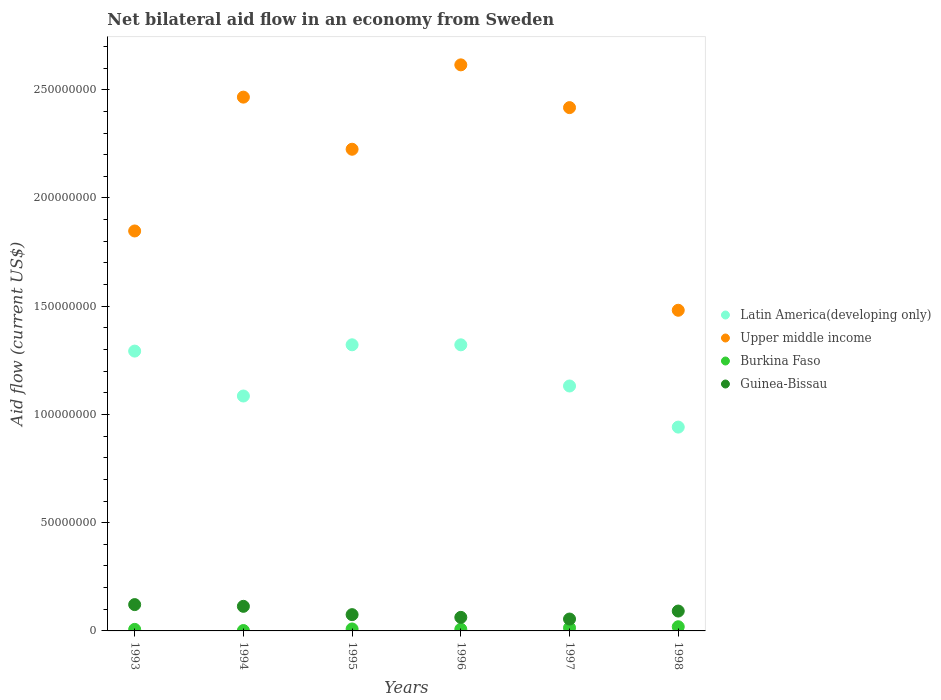How many different coloured dotlines are there?
Your answer should be compact. 4. What is the net bilateral aid flow in Latin America(developing only) in 1998?
Your answer should be compact. 9.42e+07. Across all years, what is the maximum net bilateral aid flow in Upper middle income?
Your answer should be very brief. 2.61e+08. Across all years, what is the minimum net bilateral aid flow in Latin America(developing only)?
Your answer should be compact. 9.42e+07. In which year was the net bilateral aid flow in Upper middle income maximum?
Provide a short and direct response. 1996. In which year was the net bilateral aid flow in Burkina Faso minimum?
Offer a terse response. 1994. What is the total net bilateral aid flow in Upper middle income in the graph?
Make the answer very short. 1.31e+09. What is the difference between the net bilateral aid flow in Guinea-Bissau in 1993 and that in 1995?
Offer a very short reply. 4.64e+06. What is the difference between the net bilateral aid flow in Guinea-Bissau in 1995 and the net bilateral aid flow in Upper middle income in 1996?
Offer a terse response. -2.54e+08. What is the average net bilateral aid flow in Guinea-Bissau per year?
Provide a succinct answer. 8.66e+06. In the year 1994, what is the difference between the net bilateral aid flow in Guinea-Bissau and net bilateral aid flow in Burkina Faso?
Your answer should be compact. 1.12e+07. In how many years, is the net bilateral aid flow in Latin America(developing only) greater than 10000000 US$?
Your answer should be very brief. 6. What is the ratio of the net bilateral aid flow in Burkina Faso in 1996 to that in 1997?
Keep it short and to the point. 0.55. Is the net bilateral aid flow in Upper middle income in 1995 less than that in 1997?
Make the answer very short. Yes. Is the difference between the net bilateral aid flow in Guinea-Bissau in 1993 and 1994 greater than the difference between the net bilateral aid flow in Burkina Faso in 1993 and 1994?
Make the answer very short. Yes. What is the difference between the highest and the lowest net bilateral aid flow in Upper middle income?
Provide a succinct answer. 1.13e+08. In how many years, is the net bilateral aid flow in Burkina Faso greater than the average net bilateral aid flow in Burkina Faso taken over all years?
Give a very brief answer. 2. Is it the case that in every year, the sum of the net bilateral aid flow in Guinea-Bissau and net bilateral aid flow in Burkina Faso  is greater than the sum of net bilateral aid flow in Latin America(developing only) and net bilateral aid flow in Upper middle income?
Give a very brief answer. Yes. Does the graph contain any zero values?
Ensure brevity in your answer.  No. How are the legend labels stacked?
Make the answer very short. Vertical. What is the title of the graph?
Provide a succinct answer. Net bilateral aid flow in an economy from Sweden. What is the Aid flow (current US$) of Latin America(developing only) in 1993?
Give a very brief answer. 1.29e+08. What is the Aid flow (current US$) of Upper middle income in 1993?
Give a very brief answer. 1.85e+08. What is the Aid flow (current US$) in Burkina Faso in 1993?
Give a very brief answer. 7.10e+05. What is the Aid flow (current US$) of Guinea-Bissau in 1993?
Give a very brief answer. 1.22e+07. What is the Aid flow (current US$) of Latin America(developing only) in 1994?
Provide a succinct answer. 1.09e+08. What is the Aid flow (current US$) in Upper middle income in 1994?
Provide a succinct answer. 2.47e+08. What is the Aid flow (current US$) in Burkina Faso in 1994?
Make the answer very short. 1.80e+05. What is the Aid flow (current US$) of Guinea-Bissau in 1994?
Provide a succinct answer. 1.14e+07. What is the Aid flow (current US$) in Latin America(developing only) in 1995?
Keep it short and to the point. 1.32e+08. What is the Aid flow (current US$) of Upper middle income in 1995?
Your answer should be very brief. 2.22e+08. What is the Aid flow (current US$) of Burkina Faso in 1995?
Your answer should be very brief. 9.10e+05. What is the Aid flow (current US$) in Guinea-Bissau in 1995?
Keep it short and to the point. 7.52e+06. What is the Aid flow (current US$) in Latin America(developing only) in 1996?
Provide a succinct answer. 1.32e+08. What is the Aid flow (current US$) of Upper middle income in 1996?
Make the answer very short. 2.61e+08. What is the Aid flow (current US$) in Burkina Faso in 1996?
Ensure brevity in your answer.  7.90e+05. What is the Aid flow (current US$) in Guinea-Bissau in 1996?
Offer a terse response. 6.26e+06. What is the Aid flow (current US$) in Latin America(developing only) in 1997?
Your response must be concise. 1.13e+08. What is the Aid flow (current US$) in Upper middle income in 1997?
Ensure brevity in your answer.  2.42e+08. What is the Aid flow (current US$) of Burkina Faso in 1997?
Your response must be concise. 1.44e+06. What is the Aid flow (current US$) in Guinea-Bissau in 1997?
Offer a terse response. 5.49e+06. What is the Aid flow (current US$) of Latin America(developing only) in 1998?
Offer a very short reply. 9.42e+07. What is the Aid flow (current US$) in Upper middle income in 1998?
Your response must be concise. 1.48e+08. What is the Aid flow (current US$) in Burkina Faso in 1998?
Provide a succinct answer. 1.93e+06. What is the Aid flow (current US$) in Guinea-Bissau in 1998?
Your response must be concise. 9.18e+06. Across all years, what is the maximum Aid flow (current US$) in Latin America(developing only)?
Offer a very short reply. 1.32e+08. Across all years, what is the maximum Aid flow (current US$) in Upper middle income?
Give a very brief answer. 2.61e+08. Across all years, what is the maximum Aid flow (current US$) in Burkina Faso?
Give a very brief answer. 1.93e+06. Across all years, what is the maximum Aid flow (current US$) of Guinea-Bissau?
Make the answer very short. 1.22e+07. Across all years, what is the minimum Aid flow (current US$) in Latin America(developing only)?
Your answer should be compact. 9.42e+07. Across all years, what is the minimum Aid flow (current US$) of Upper middle income?
Keep it short and to the point. 1.48e+08. Across all years, what is the minimum Aid flow (current US$) in Guinea-Bissau?
Offer a very short reply. 5.49e+06. What is the total Aid flow (current US$) of Latin America(developing only) in the graph?
Ensure brevity in your answer.  7.09e+08. What is the total Aid flow (current US$) of Upper middle income in the graph?
Provide a succinct answer. 1.31e+09. What is the total Aid flow (current US$) in Burkina Faso in the graph?
Provide a succinct answer. 5.96e+06. What is the total Aid flow (current US$) of Guinea-Bissau in the graph?
Your answer should be compact. 5.20e+07. What is the difference between the Aid flow (current US$) in Latin America(developing only) in 1993 and that in 1994?
Offer a very short reply. 2.08e+07. What is the difference between the Aid flow (current US$) of Upper middle income in 1993 and that in 1994?
Your answer should be very brief. -6.18e+07. What is the difference between the Aid flow (current US$) in Burkina Faso in 1993 and that in 1994?
Make the answer very short. 5.30e+05. What is the difference between the Aid flow (current US$) of Latin America(developing only) in 1993 and that in 1995?
Provide a succinct answer. -2.91e+06. What is the difference between the Aid flow (current US$) in Upper middle income in 1993 and that in 1995?
Make the answer very short. -3.78e+07. What is the difference between the Aid flow (current US$) of Guinea-Bissau in 1993 and that in 1995?
Make the answer very short. 4.64e+06. What is the difference between the Aid flow (current US$) in Latin America(developing only) in 1993 and that in 1996?
Ensure brevity in your answer.  -2.90e+06. What is the difference between the Aid flow (current US$) of Upper middle income in 1993 and that in 1996?
Give a very brief answer. -7.67e+07. What is the difference between the Aid flow (current US$) in Guinea-Bissau in 1993 and that in 1996?
Provide a succinct answer. 5.90e+06. What is the difference between the Aid flow (current US$) of Latin America(developing only) in 1993 and that in 1997?
Provide a short and direct response. 1.61e+07. What is the difference between the Aid flow (current US$) of Upper middle income in 1993 and that in 1997?
Ensure brevity in your answer.  -5.70e+07. What is the difference between the Aid flow (current US$) in Burkina Faso in 1993 and that in 1997?
Provide a short and direct response. -7.30e+05. What is the difference between the Aid flow (current US$) in Guinea-Bissau in 1993 and that in 1997?
Keep it short and to the point. 6.67e+06. What is the difference between the Aid flow (current US$) of Latin America(developing only) in 1993 and that in 1998?
Your answer should be very brief. 3.51e+07. What is the difference between the Aid flow (current US$) of Upper middle income in 1993 and that in 1998?
Give a very brief answer. 3.66e+07. What is the difference between the Aid flow (current US$) in Burkina Faso in 1993 and that in 1998?
Offer a very short reply. -1.22e+06. What is the difference between the Aid flow (current US$) in Guinea-Bissau in 1993 and that in 1998?
Offer a terse response. 2.98e+06. What is the difference between the Aid flow (current US$) in Latin America(developing only) in 1994 and that in 1995?
Provide a succinct answer. -2.37e+07. What is the difference between the Aid flow (current US$) of Upper middle income in 1994 and that in 1995?
Offer a very short reply. 2.41e+07. What is the difference between the Aid flow (current US$) in Burkina Faso in 1994 and that in 1995?
Keep it short and to the point. -7.30e+05. What is the difference between the Aid flow (current US$) in Guinea-Bissau in 1994 and that in 1995?
Your answer should be compact. 3.84e+06. What is the difference between the Aid flow (current US$) in Latin America(developing only) in 1994 and that in 1996?
Provide a short and direct response. -2.36e+07. What is the difference between the Aid flow (current US$) in Upper middle income in 1994 and that in 1996?
Make the answer very short. -1.49e+07. What is the difference between the Aid flow (current US$) in Burkina Faso in 1994 and that in 1996?
Offer a terse response. -6.10e+05. What is the difference between the Aid flow (current US$) in Guinea-Bissau in 1994 and that in 1996?
Provide a succinct answer. 5.10e+06. What is the difference between the Aid flow (current US$) in Latin America(developing only) in 1994 and that in 1997?
Offer a terse response. -4.63e+06. What is the difference between the Aid flow (current US$) in Upper middle income in 1994 and that in 1997?
Provide a succinct answer. 4.84e+06. What is the difference between the Aid flow (current US$) in Burkina Faso in 1994 and that in 1997?
Your response must be concise. -1.26e+06. What is the difference between the Aid flow (current US$) in Guinea-Bissau in 1994 and that in 1997?
Provide a short and direct response. 5.87e+06. What is the difference between the Aid flow (current US$) in Latin America(developing only) in 1994 and that in 1998?
Your answer should be compact. 1.44e+07. What is the difference between the Aid flow (current US$) of Upper middle income in 1994 and that in 1998?
Give a very brief answer. 9.84e+07. What is the difference between the Aid flow (current US$) of Burkina Faso in 1994 and that in 1998?
Ensure brevity in your answer.  -1.75e+06. What is the difference between the Aid flow (current US$) of Guinea-Bissau in 1994 and that in 1998?
Your answer should be very brief. 2.18e+06. What is the difference between the Aid flow (current US$) in Upper middle income in 1995 and that in 1996?
Ensure brevity in your answer.  -3.90e+07. What is the difference between the Aid flow (current US$) in Guinea-Bissau in 1995 and that in 1996?
Ensure brevity in your answer.  1.26e+06. What is the difference between the Aid flow (current US$) in Latin America(developing only) in 1995 and that in 1997?
Make the answer very short. 1.90e+07. What is the difference between the Aid flow (current US$) in Upper middle income in 1995 and that in 1997?
Your answer should be compact. -1.92e+07. What is the difference between the Aid flow (current US$) in Burkina Faso in 1995 and that in 1997?
Your answer should be very brief. -5.30e+05. What is the difference between the Aid flow (current US$) of Guinea-Bissau in 1995 and that in 1997?
Offer a very short reply. 2.03e+06. What is the difference between the Aid flow (current US$) in Latin America(developing only) in 1995 and that in 1998?
Your answer should be compact. 3.80e+07. What is the difference between the Aid flow (current US$) of Upper middle income in 1995 and that in 1998?
Give a very brief answer. 7.44e+07. What is the difference between the Aid flow (current US$) in Burkina Faso in 1995 and that in 1998?
Offer a terse response. -1.02e+06. What is the difference between the Aid flow (current US$) of Guinea-Bissau in 1995 and that in 1998?
Give a very brief answer. -1.66e+06. What is the difference between the Aid flow (current US$) in Latin America(developing only) in 1996 and that in 1997?
Ensure brevity in your answer.  1.90e+07. What is the difference between the Aid flow (current US$) of Upper middle income in 1996 and that in 1997?
Keep it short and to the point. 1.98e+07. What is the difference between the Aid flow (current US$) of Burkina Faso in 1996 and that in 1997?
Offer a terse response. -6.50e+05. What is the difference between the Aid flow (current US$) in Guinea-Bissau in 1996 and that in 1997?
Keep it short and to the point. 7.70e+05. What is the difference between the Aid flow (current US$) of Latin America(developing only) in 1996 and that in 1998?
Provide a short and direct response. 3.80e+07. What is the difference between the Aid flow (current US$) in Upper middle income in 1996 and that in 1998?
Keep it short and to the point. 1.13e+08. What is the difference between the Aid flow (current US$) in Burkina Faso in 1996 and that in 1998?
Offer a very short reply. -1.14e+06. What is the difference between the Aid flow (current US$) in Guinea-Bissau in 1996 and that in 1998?
Your answer should be very brief. -2.92e+06. What is the difference between the Aid flow (current US$) in Latin America(developing only) in 1997 and that in 1998?
Your response must be concise. 1.90e+07. What is the difference between the Aid flow (current US$) of Upper middle income in 1997 and that in 1998?
Provide a short and direct response. 9.36e+07. What is the difference between the Aid flow (current US$) of Burkina Faso in 1997 and that in 1998?
Ensure brevity in your answer.  -4.90e+05. What is the difference between the Aid flow (current US$) of Guinea-Bissau in 1997 and that in 1998?
Your answer should be compact. -3.69e+06. What is the difference between the Aid flow (current US$) in Latin America(developing only) in 1993 and the Aid flow (current US$) in Upper middle income in 1994?
Offer a terse response. -1.17e+08. What is the difference between the Aid flow (current US$) in Latin America(developing only) in 1993 and the Aid flow (current US$) in Burkina Faso in 1994?
Keep it short and to the point. 1.29e+08. What is the difference between the Aid flow (current US$) in Latin America(developing only) in 1993 and the Aid flow (current US$) in Guinea-Bissau in 1994?
Your response must be concise. 1.18e+08. What is the difference between the Aid flow (current US$) of Upper middle income in 1993 and the Aid flow (current US$) of Burkina Faso in 1994?
Make the answer very short. 1.85e+08. What is the difference between the Aid flow (current US$) of Upper middle income in 1993 and the Aid flow (current US$) of Guinea-Bissau in 1994?
Your answer should be very brief. 1.73e+08. What is the difference between the Aid flow (current US$) of Burkina Faso in 1993 and the Aid flow (current US$) of Guinea-Bissau in 1994?
Your answer should be compact. -1.06e+07. What is the difference between the Aid flow (current US$) in Latin America(developing only) in 1993 and the Aid flow (current US$) in Upper middle income in 1995?
Your response must be concise. -9.32e+07. What is the difference between the Aid flow (current US$) in Latin America(developing only) in 1993 and the Aid flow (current US$) in Burkina Faso in 1995?
Your answer should be compact. 1.28e+08. What is the difference between the Aid flow (current US$) of Latin America(developing only) in 1993 and the Aid flow (current US$) of Guinea-Bissau in 1995?
Provide a succinct answer. 1.22e+08. What is the difference between the Aid flow (current US$) in Upper middle income in 1993 and the Aid flow (current US$) in Burkina Faso in 1995?
Provide a succinct answer. 1.84e+08. What is the difference between the Aid flow (current US$) in Upper middle income in 1993 and the Aid flow (current US$) in Guinea-Bissau in 1995?
Provide a succinct answer. 1.77e+08. What is the difference between the Aid flow (current US$) in Burkina Faso in 1993 and the Aid flow (current US$) in Guinea-Bissau in 1995?
Your answer should be compact. -6.81e+06. What is the difference between the Aid flow (current US$) in Latin America(developing only) in 1993 and the Aid flow (current US$) in Upper middle income in 1996?
Your answer should be very brief. -1.32e+08. What is the difference between the Aid flow (current US$) in Latin America(developing only) in 1993 and the Aid flow (current US$) in Burkina Faso in 1996?
Offer a very short reply. 1.28e+08. What is the difference between the Aid flow (current US$) in Latin America(developing only) in 1993 and the Aid flow (current US$) in Guinea-Bissau in 1996?
Make the answer very short. 1.23e+08. What is the difference between the Aid flow (current US$) in Upper middle income in 1993 and the Aid flow (current US$) in Burkina Faso in 1996?
Make the answer very short. 1.84e+08. What is the difference between the Aid flow (current US$) in Upper middle income in 1993 and the Aid flow (current US$) in Guinea-Bissau in 1996?
Keep it short and to the point. 1.78e+08. What is the difference between the Aid flow (current US$) in Burkina Faso in 1993 and the Aid flow (current US$) in Guinea-Bissau in 1996?
Your answer should be very brief. -5.55e+06. What is the difference between the Aid flow (current US$) of Latin America(developing only) in 1993 and the Aid flow (current US$) of Upper middle income in 1997?
Offer a very short reply. -1.12e+08. What is the difference between the Aid flow (current US$) of Latin America(developing only) in 1993 and the Aid flow (current US$) of Burkina Faso in 1997?
Give a very brief answer. 1.28e+08. What is the difference between the Aid flow (current US$) of Latin America(developing only) in 1993 and the Aid flow (current US$) of Guinea-Bissau in 1997?
Give a very brief answer. 1.24e+08. What is the difference between the Aid flow (current US$) in Upper middle income in 1993 and the Aid flow (current US$) in Burkina Faso in 1997?
Give a very brief answer. 1.83e+08. What is the difference between the Aid flow (current US$) in Upper middle income in 1993 and the Aid flow (current US$) in Guinea-Bissau in 1997?
Your answer should be compact. 1.79e+08. What is the difference between the Aid flow (current US$) in Burkina Faso in 1993 and the Aid flow (current US$) in Guinea-Bissau in 1997?
Offer a terse response. -4.78e+06. What is the difference between the Aid flow (current US$) in Latin America(developing only) in 1993 and the Aid flow (current US$) in Upper middle income in 1998?
Offer a very short reply. -1.89e+07. What is the difference between the Aid flow (current US$) of Latin America(developing only) in 1993 and the Aid flow (current US$) of Burkina Faso in 1998?
Your response must be concise. 1.27e+08. What is the difference between the Aid flow (current US$) in Latin America(developing only) in 1993 and the Aid flow (current US$) in Guinea-Bissau in 1998?
Provide a short and direct response. 1.20e+08. What is the difference between the Aid flow (current US$) of Upper middle income in 1993 and the Aid flow (current US$) of Burkina Faso in 1998?
Provide a succinct answer. 1.83e+08. What is the difference between the Aid flow (current US$) in Upper middle income in 1993 and the Aid flow (current US$) in Guinea-Bissau in 1998?
Give a very brief answer. 1.76e+08. What is the difference between the Aid flow (current US$) of Burkina Faso in 1993 and the Aid flow (current US$) of Guinea-Bissau in 1998?
Your answer should be compact. -8.47e+06. What is the difference between the Aid flow (current US$) in Latin America(developing only) in 1994 and the Aid flow (current US$) in Upper middle income in 1995?
Ensure brevity in your answer.  -1.14e+08. What is the difference between the Aid flow (current US$) in Latin America(developing only) in 1994 and the Aid flow (current US$) in Burkina Faso in 1995?
Your answer should be compact. 1.08e+08. What is the difference between the Aid flow (current US$) in Latin America(developing only) in 1994 and the Aid flow (current US$) in Guinea-Bissau in 1995?
Give a very brief answer. 1.01e+08. What is the difference between the Aid flow (current US$) in Upper middle income in 1994 and the Aid flow (current US$) in Burkina Faso in 1995?
Provide a short and direct response. 2.46e+08. What is the difference between the Aid flow (current US$) of Upper middle income in 1994 and the Aid flow (current US$) of Guinea-Bissau in 1995?
Keep it short and to the point. 2.39e+08. What is the difference between the Aid flow (current US$) in Burkina Faso in 1994 and the Aid flow (current US$) in Guinea-Bissau in 1995?
Keep it short and to the point. -7.34e+06. What is the difference between the Aid flow (current US$) of Latin America(developing only) in 1994 and the Aid flow (current US$) of Upper middle income in 1996?
Make the answer very short. -1.53e+08. What is the difference between the Aid flow (current US$) in Latin America(developing only) in 1994 and the Aid flow (current US$) in Burkina Faso in 1996?
Your response must be concise. 1.08e+08. What is the difference between the Aid flow (current US$) of Latin America(developing only) in 1994 and the Aid flow (current US$) of Guinea-Bissau in 1996?
Provide a succinct answer. 1.02e+08. What is the difference between the Aid flow (current US$) in Upper middle income in 1994 and the Aid flow (current US$) in Burkina Faso in 1996?
Ensure brevity in your answer.  2.46e+08. What is the difference between the Aid flow (current US$) of Upper middle income in 1994 and the Aid flow (current US$) of Guinea-Bissau in 1996?
Provide a succinct answer. 2.40e+08. What is the difference between the Aid flow (current US$) in Burkina Faso in 1994 and the Aid flow (current US$) in Guinea-Bissau in 1996?
Your answer should be compact. -6.08e+06. What is the difference between the Aid flow (current US$) in Latin America(developing only) in 1994 and the Aid flow (current US$) in Upper middle income in 1997?
Provide a short and direct response. -1.33e+08. What is the difference between the Aid flow (current US$) in Latin America(developing only) in 1994 and the Aid flow (current US$) in Burkina Faso in 1997?
Give a very brief answer. 1.07e+08. What is the difference between the Aid flow (current US$) of Latin America(developing only) in 1994 and the Aid flow (current US$) of Guinea-Bissau in 1997?
Your answer should be compact. 1.03e+08. What is the difference between the Aid flow (current US$) of Upper middle income in 1994 and the Aid flow (current US$) of Burkina Faso in 1997?
Offer a very short reply. 2.45e+08. What is the difference between the Aid flow (current US$) in Upper middle income in 1994 and the Aid flow (current US$) in Guinea-Bissau in 1997?
Provide a short and direct response. 2.41e+08. What is the difference between the Aid flow (current US$) in Burkina Faso in 1994 and the Aid flow (current US$) in Guinea-Bissau in 1997?
Your answer should be very brief. -5.31e+06. What is the difference between the Aid flow (current US$) in Latin America(developing only) in 1994 and the Aid flow (current US$) in Upper middle income in 1998?
Ensure brevity in your answer.  -3.96e+07. What is the difference between the Aid flow (current US$) in Latin America(developing only) in 1994 and the Aid flow (current US$) in Burkina Faso in 1998?
Ensure brevity in your answer.  1.07e+08. What is the difference between the Aid flow (current US$) of Latin America(developing only) in 1994 and the Aid flow (current US$) of Guinea-Bissau in 1998?
Keep it short and to the point. 9.93e+07. What is the difference between the Aid flow (current US$) in Upper middle income in 1994 and the Aid flow (current US$) in Burkina Faso in 1998?
Provide a short and direct response. 2.45e+08. What is the difference between the Aid flow (current US$) in Upper middle income in 1994 and the Aid flow (current US$) in Guinea-Bissau in 1998?
Offer a terse response. 2.37e+08. What is the difference between the Aid flow (current US$) in Burkina Faso in 1994 and the Aid flow (current US$) in Guinea-Bissau in 1998?
Provide a short and direct response. -9.00e+06. What is the difference between the Aid flow (current US$) in Latin America(developing only) in 1995 and the Aid flow (current US$) in Upper middle income in 1996?
Keep it short and to the point. -1.29e+08. What is the difference between the Aid flow (current US$) in Latin America(developing only) in 1995 and the Aid flow (current US$) in Burkina Faso in 1996?
Offer a very short reply. 1.31e+08. What is the difference between the Aid flow (current US$) in Latin America(developing only) in 1995 and the Aid flow (current US$) in Guinea-Bissau in 1996?
Give a very brief answer. 1.26e+08. What is the difference between the Aid flow (current US$) of Upper middle income in 1995 and the Aid flow (current US$) of Burkina Faso in 1996?
Your response must be concise. 2.22e+08. What is the difference between the Aid flow (current US$) of Upper middle income in 1995 and the Aid flow (current US$) of Guinea-Bissau in 1996?
Offer a terse response. 2.16e+08. What is the difference between the Aid flow (current US$) of Burkina Faso in 1995 and the Aid flow (current US$) of Guinea-Bissau in 1996?
Offer a terse response. -5.35e+06. What is the difference between the Aid flow (current US$) of Latin America(developing only) in 1995 and the Aid flow (current US$) of Upper middle income in 1997?
Offer a very short reply. -1.10e+08. What is the difference between the Aid flow (current US$) in Latin America(developing only) in 1995 and the Aid flow (current US$) in Burkina Faso in 1997?
Offer a terse response. 1.31e+08. What is the difference between the Aid flow (current US$) of Latin America(developing only) in 1995 and the Aid flow (current US$) of Guinea-Bissau in 1997?
Make the answer very short. 1.27e+08. What is the difference between the Aid flow (current US$) in Upper middle income in 1995 and the Aid flow (current US$) in Burkina Faso in 1997?
Ensure brevity in your answer.  2.21e+08. What is the difference between the Aid flow (current US$) in Upper middle income in 1995 and the Aid flow (current US$) in Guinea-Bissau in 1997?
Ensure brevity in your answer.  2.17e+08. What is the difference between the Aid flow (current US$) in Burkina Faso in 1995 and the Aid flow (current US$) in Guinea-Bissau in 1997?
Offer a terse response. -4.58e+06. What is the difference between the Aid flow (current US$) of Latin America(developing only) in 1995 and the Aid flow (current US$) of Upper middle income in 1998?
Your answer should be compact. -1.60e+07. What is the difference between the Aid flow (current US$) of Latin America(developing only) in 1995 and the Aid flow (current US$) of Burkina Faso in 1998?
Provide a short and direct response. 1.30e+08. What is the difference between the Aid flow (current US$) of Latin America(developing only) in 1995 and the Aid flow (current US$) of Guinea-Bissau in 1998?
Your answer should be compact. 1.23e+08. What is the difference between the Aid flow (current US$) in Upper middle income in 1995 and the Aid flow (current US$) in Burkina Faso in 1998?
Offer a very short reply. 2.21e+08. What is the difference between the Aid flow (current US$) in Upper middle income in 1995 and the Aid flow (current US$) in Guinea-Bissau in 1998?
Offer a terse response. 2.13e+08. What is the difference between the Aid flow (current US$) of Burkina Faso in 1995 and the Aid flow (current US$) of Guinea-Bissau in 1998?
Your answer should be compact. -8.27e+06. What is the difference between the Aid flow (current US$) of Latin America(developing only) in 1996 and the Aid flow (current US$) of Upper middle income in 1997?
Your response must be concise. -1.10e+08. What is the difference between the Aid flow (current US$) of Latin America(developing only) in 1996 and the Aid flow (current US$) of Burkina Faso in 1997?
Your answer should be compact. 1.31e+08. What is the difference between the Aid flow (current US$) of Latin America(developing only) in 1996 and the Aid flow (current US$) of Guinea-Bissau in 1997?
Keep it short and to the point. 1.27e+08. What is the difference between the Aid flow (current US$) of Upper middle income in 1996 and the Aid flow (current US$) of Burkina Faso in 1997?
Provide a succinct answer. 2.60e+08. What is the difference between the Aid flow (current US$) of Upper middle income in 1996 and the Aid flow (current US$) of Guinea-Bissau in 1997?
Provide a short and direct response. 2.56e+08. What is the difference between the Aid flow (current US$) of Burkina Faso in 1996 and the Aid flow (current US$) of Guinea-Bissau in 1997?
Give a very brief answer. -4.70e+06. What is the difference between the Aid flow (current US$) of Latin America(developing only) in 1996 and the Aid flow (current US$) of Upper middle income in 1998?
Offer a very short reply. -1.60e+07. What is the difference between the Aid flow (current US$) in Latin America(developing only) in 1996 and the Aid flow (current US$) in Burkina Faso in 1998?
Your response must be concise. 1.30e+08. What is the difference between the Aid flow (current US$) of Latin America(developing only) in 1996 and the Aid flow (current US$) of Guinea-Bissau in 1998?
Your response must be concise. 1.23e+08. What is the difference between the Aid flow (current US$) of Upper middle income in 1996 and the Aid flow (current US$) of Burkina Faso in 1998?
Provide a short and direct response. 2.60e+08. What is the difference between the Aid flow (current US$) of Upper middle income in 1996 and the Aid flow (current US$) of Guinea-Bissau in 1998?
Ensure brevity in your answer.  2.52e+08. What is the difference between the Aid flow (current US$) in Burkina Faso in 1996 and the Aid flow (current US$) in Guinea-Bissau in 1998?
Offer a terse response. -8.39e+06. What is the difference between the Aid flow (current US$) in Latin America(developing only) in 1997 and the Aid flow (current US$) in Upper middle income in 1998?
Keep it short and to the point. -3.50e+07. What is the difference between the Aid flow (current US$) of Latin America(developing only) in 1997 and the Aid flow (current US$) of Burkina Faso in 1998?
Offer a terse response. 1.11e+08. What is the difference between the Aid flow (current US$) of Latin America(developing only) in 1997 and the Aid flow (current US$) of Guinea-Bissau in 1998?
Give a very brief answer. 1.04e+08. What is the difference between the Aid flow (current US$) in Upper middle income in 1997 and the Aid flow (current US$) in Burkina Faso in 1998?
Your answer should be very brief. 2.40e+08. What is the difference between the Aid flow (current US$) of Upper middle income in 1997 and the Aid flow (current US$) of Guinea-Bissau in 1998?
Keep it short and to the point. 2.33e+08. What is the difference between the Aid flow (current US$) in Burkina Faso in 1997 and the Aid flow (current US$) in Guinea-Bissau in 1998?
Your answer should be compact. -7.74e+06. What is the average Aid flow (current US$) of Latin America(developing only) per year?
Provide a succinct answer. 1.18e+08. What is the average Aid flow (current US$) in Upper middle income per year?
Your answer should be compact. 2.18e+08. What is the average Aid flow (current US$) in Burkina Faso per year?
Give a very brief answer. 9.93e+05. What is the average Aid flow (current US$) in Guinea-Bissau per year?
Your answer should be compact. 8.66e+06. In the year 1993, what is the difference between the Aid flow (current US$) of Latin America(developing only) and Aid flow (current US$) of Upper middle income?
Your answer should be very brief. -5.55e+07. In the year 1993, what is the difference between the Aid flow (current US$) of Latin America(developing only) and Aid flow (current US$) of Burkina Faso?
Offer a very short reply. 1.29e+08. In the year 1993, what is the difference between the Aid flow (current US$) of Latin America(developing only) and Aid flow (current US$) of Guinea-Bissau?
Offer a terse response. 1.17e+08. In the year 1993, what is the difference between the Aid flow (current US$) in Upper middle income and Aid flow (current US$) in Burkina Faso?
Keep it short and to the point. 1.84e+08. In the year 1993, what is the difference between the Aid flow (current US$) of Upper middle income and Aid flow (current US$) of Guinea-Bissau?
Provide a succinct answer. 1.73e+08. In the year 1993, what is the difference between the Aid flow (current US$) in Burkina Faso and Aid flow (current US$) in Guinea-Bissau?
Keep it short and to the point. -1.14e+07. In the year 1994, what is the difference between the Aid flow (current US$) of Latin America(developing only) and Aid flow (current US$) of Upper middle income?
Offer a terse response. -1.38e+08. In the year 1994, what is the difference between the Aid flow (current US$) of Latin America(developing only) and Aid flow (current US$) of Burkina Faso?
Your response must be concise. 1.08e+08. In the year 1994, what is the difference between the Aid flow (current US$) in Latin America(developing only) and Aid flow (current US$) in Guinea-Bissau?
Provide a succinct answer. 9.72e+07. In the year 1994, what is the difference between the Aid flow (current US$) of Upper middle income and Aid flow (current US$) of Burkina Faso?
Keep it short and to the point. 2.46e+08. In the year 1994, what is the difference between the Aid flow (current US$) in Upper middle income and Aid flow (current US$) in Guinea-Bissau?
Provide a succinct answer. 2.35e+08. In the year 1994, what is the difference between the Aid flow (current US$) of Burkina Faso and Aid flow (current US$) of Guinea-Bissau?
Your answer should be compact. -1.12e+07. In the year 1995, what is the difference between the Aid flow (current US$) in Latin America(developing only) and Aid flow (current US$) in Upper middle income?
Your answer should be compact. -9.03e+07. In the year 1995, what is the difference between the Aid flow (current US$) in Latin America(developing only) and Aid flow (current US$) in Burkina Faso?
Offer a terse response. 1.31e+08. In the year 1995, what is the difference between the Aid flow (current US$) of Latin America(developing only) and Aid flow (current US$) of Guinea-Bissau?
Offer a terse response. 1.25e+08. In the year 1995, what is the difference between the Aid flow (current US$) of Upper middle income and Aid flow (current US$) of Burkina Faso?
Give a very brief answer. 2.22e+08. In the year 1995, what is the difference between the Aid flow (current US$) in Upper middle income and Aid flow (current US$) in Guinea-Bissau?
Provide a short and direct response. 2.15e+08. In the year 1995, what is the difference between the Aid flow (current US$) in Burkina Faso and Aid flow (current US$) in Guinea-Bissau?
Keep it short and to the point. -6.61e+06. In the year 1996, what is the difference between the Aid flow (current US$) of Latin America(developing only) and Aid flow (current US$) of Upper middle income?
Keep it short and to the point. -1.29e+08. In the year 1996, what is the difference between the Aid flow (current US$) of Latin America(developing only) and Aid flow (current US$) of Burkina Faso?
Your answer should be very brief. 1.31e+08. In the year 1996, what is the difference between the Aid flow (current US$) in Latin America(developing only) and Aid flow (current US$) in Guinea-Bissau?
Offer a very short reply. 1.26e+08. In the year 1996, what is the difference between the Aid flow (current US$) in Upper middle income and Aid flow (current US$) in Burkina Faso?
Make the answer very short. 2.61e+08. In the year 1996, what is the difference between the Aid flow (current US$) of Upper middle income and Aid flow (current US$) of Guinea-Bissau?
Offer a very short reply. 2.55e+08. In the year 1996, what is the difference between the Aid flow (current US$) of Burkina Faso and Aid flow (current US$) of Guinea-Bissau?
Provide a short and direct response. -5.47e+06. In the year 1997, what is the difference between the Aid flow (current US$) in Latin America(developing only) and Aid flow (current US$) in Upper middle income?
Make the answer very short. -1.29e+08. In the year 1997, what is the difference between the Aid flow (current US$) in Latin America(developing only) and Aid flow (current US$) in Burkina Faso?
Offer a very short reply. 1.12e+08. In the year 1997, what is the difference between the Aid flow (current US$) in Latin America(developing only) and Aid flow (current US$) in Guinea-Bissau?
Provide a short and direct response. 1.08e+08. In the year 1997, what is the difference between the Aid flow (current US$) of Upper middle income and Aid flow (current US$) of Burkina Faso?
Your response must be concise. 2.40e+08. In the year 1997, what is the difference between the Aid flow (current US$) in Upper middle income and Aid flow (current US$) in Guinea-Bissau?
Your answer should be compact. 2.36e+08. In the year 1997, what is the difference between the Aid flow (current US$) of Burkina Faso and Aid flow (current US$) of Guinea-Bissau?
Your answer should be compact. -4.05e+06. In the year 1998, what is the difference between the Aid flow (current US$) of Latin America(developing only) and Aid flow (current US$) of Upper middle income?
Ensure brevity in your answer.  -5.40e+07. In the year 1998, what is the difference between the Aid flow (current US$) in Latin America(developing only) and Aid flow (current US$) in Burkina Faso?
Your answer should be compact. 9.22e+07. In the year 1998, what is the difference between the Aid flow (current US$) in Latin America(developing only) and Aid flow (current US$) in Guinea-Bissau?
Offer a very short reply. 8.50e+07. In the year 1998, what is the difference between the Aid flow (current US$) of Upper middle income and Aid flow (current US$) of Burkina Faso?
Your answer should be very brief. 1.46e+08. In the year 1998, what is the difference between the Aid flow (current US$) of Upper middle income and Aid flow (current US$) of Guinea-Bissau?
Provide a succinct answer. 1.39e+08. In the year 1998, what is the difference between the Aid flow (current US$) of Burkina Faso and Aid flow (current US$) of Guinea-Bissau?
Make the answer very short. -7.25e+06. What is the ratio of the Aid flow (current US$) of Latin America(developing only) in 1993 to that in 1994?
Provide a succinct answer. 1.19. What is the ratio of the Aid flow (current US$) in Upper middle income in 1993 to that in 1994?
Make the answer very short. 0.75. What is the ratio of the Aid flow (current US$) in Burkina Faso in 1993 to that in 1994?
Your answer should be very brief. 3.94. What is the ratio of the Aid flow (current US$) in Guinea-Bissau in 1993 to that in 1994?
Ensure brevity in your answer.  1.07. What is the ratio of the Aid flow (current US$) of Upper middle income in 1993 to that in 1995?
Ensure brevity in your answer.  0.83. What is the ratio of the Aid flow (current US$) of Burkina Faso in 1993 to that in 1995?
Ensure brevity in your answer.  0.78. What is the ratio of the Aid flow (current US$) in Guinea-Bissau in 1993 to that in 1995?
Offer a very short reply. 1.62. What is the ratio of the Aid flow (current US$) of Latin America(developing only) in 1993 to that in 1996?
Your response must be concise. 0.98. What is the ratio of the Aid flow (current US$) in Upper middle income in 1993 to that in 1996?
Keep it short and to the point. 0.71. What is the ratio of the Aid flow (current US$) of Burkina Faso in 1993 to that in 1996?
Your answer should be compact. 0.9. What is the ratio of the Aid flow (current US$) of Guinea-Bissau in 1993 to that in 1996?
Make the answer very short. 1.94. What is the ratio of the Aid flow (current US$) in Latin America(developing only) in 1993 to that in 1997?
Keep it short and to the point. 1.14. What is the ratio of the Aid flow (current US$) of Upper middle income in 1993 to that in 1997?
Provide a succinct answer. 0.76. What is the ratio of the Aid flow (current US$) of Burkina Faso in 1993 to that in 1997?
Make the answer very short. 0.49. What is the ratio of the Aid flow (current US$) of Guinea-Bissau in 1993 to that in 1997?
Your answer should be very brief. 2.21. What is the ratio of the Aid flow (current US$) in Latin America(developing only) in 1993 to that in 1998?
Your answer should be compact. 1.37. What is the ratio of the Aid flow (current US$) of Upper middle income in 1993 to that in 1998?
Give a very brief answer. 1.25. What is the ratio of the Aid flow (current US$) in Burkina Faso in 1993 to that in 1998?
Keep it short and to the point. 0.37. What is the ratio of the Aid flow (current US$) in Guinea-Bissau in 1993 to that in 1998?
Offer a terse response. 1.32. What is the ratio of the Aid flow (current US$) in Latin America(developing only) in 1994 to that in 1995?
Your answer should be very brief. 0.82. What is the ratio of the Aid flow (current US$) in Upper middle income in 1994 to that in 1995?
Give a very brief answer. 1.11. What is the ratio of the Aid flow (current US$) in Burkina Faso in 1994 to that in 1995?
Your response must be concise. 0.2. What is the ratio of the Aid flow (current US$) in Guinea-Bissau in 1994 to that in 1995?
Ensure brevity in your answer.  1.51. What is the ratio of the Aid flow (current US$) in Latin America(developing only) in 1994 to that in 1996?
Provide a succinct answer. 0.82. What is the ratio of the Aid flow (current US$) of Upper middle income in 1994 to that in 1996?
Ensure brevity in your answer.  0.94. What is the ratio of the Aid flow (current US$) in Burkina Faso in 1994 to that in 1996?
Your response must be concise. 0.23. What is the ratio of the Aid flow (current US$) in Guinea-Bissau in 1994 to that in 1996?
Make the answer very short. 1.81. What is the ratio of the Aid flow (current US$) of Latin America(developing only) in 1994 to that in 1997?
Provide a succinct answer. 0.96. What is the ratio of the Aid flow (current US$) of Upper middle income in 1994 to that in 1997?
Provide a short and direct response. 1.02. What is the ratio of the Aid flow (current US$) in Guinea-Bissau in 1994 to that in 1997?
Offer a terse response. 2.07. What is the ratio of the Aid flow (current US$) in Latin America(developing only) in 1994 to that in 1998?
Offer a terse response. 1.15. What is the ratio of the Aid flow (current US$) in Upper middle income in 1994 to that in 1998?
Your answer should be compact. 1.66. What is the ratio of the Aid flow (current US$) of Burkina Faso in 1994 to that in 1998?
Your answer should be compact. 0.09. What is the ratio of the Aid flow (current US$) in Guinea-Bissau in 1994 to that in 1998?
Keep it short and to the point. 1.24. What is the ratio of the Aid flow (current US$) of Upper middle income in 1995 to that in 1996?
Your answer should be very brief. 0.85. What is the ratio of the Aid flow (current US$) in Burkina Faso in 1995 to that in 1996?
Your answer should be very brief. 1.15. What is the ratio of the Aid flow (current US$) in Guinea-Bissau in 1995 to that in 1996?
Your response must be concise. 1.2. What is the ratio of the Aid flow (current US$) in Latin America(developing only) in 1995 to that in 1997?
Your answer should be compact. 1.17. What is the ratio of the Aid flow (current US$) in Upper middle income in 1995 to that in 1997?
Give a very brief answer. 0.92. What is the ratio of the Aid flow (current US$) in Burkina Faso in 1995 to that in 1997?
Make the answer very short. 0.63. What is the ratio of the Aid flow (current US$) of Guinea-Bissau in 1995 to that in 1997?
Keep it short and to the point. 1.37. What is the ratio of the Aid flow (current US$) of Latin America(developing only) in 1995 to that in 1998?
Offer a very short reply. 1.4. What is the ratio of the Aid flow (current US$) of Upper middle income in 1995 to that in 1998?
Your answer should be very brief. 1.5. What is the ratio of the Aid flow (current US$) in Burkina Faso in 1995 to that in 1998?
Provide a short and direct response. 0.47. What is the ratio of the Aid flow (current US$) in Guinea-Bissau in 1995 to that in 1998?
Offer a terse response. 0.82. What is the ratio of the Aid flow (current US$) of Latin America(developing only) in 1996 to that in 1997?
Give a very brief answer. 1.17. What is the ratio of the Aid flow (current US$) of Upper middle income in 1996 to that in 1997?
Make the answer very short. 1.08. What is the ratio of the Aid flow (current US$) of Burkina Faso in 1996 to that in 1997?
Your answer should be compact. 0.55. What is the ratio of the Aid flow (current US$) in Guinea-Bissau in 1996 to that in 1997?
Provide a short and direct response. 1.14. What is the ratio of the Aid flow (current US$) of Latin America(developing only) in 1996 to that in 1998?
Your response must be concise. 1.4. What is the ratio of the Aid flow (current US$) of Upper middle income in 1996 to that in 1998?
Offer a very short reply. 1.77. What is the ratio of the Aid flow (current US$) in Burkina Faso in 1996 to that in 1998?
Your answer should be very brief. 0.41. What is the ratio of the Aid flow (current US$) in Guinea-Bissau in 1996 to that in 1998?
Ensure brevity in your answer.  0.68. What is the ratio of the Aid flow (current US$) of Latin America(developing only) in 1997 to that in 1998?
Provide a succinct answer. 1.2. What is the ratio of the Aid flow (current US$) of Upper middle income in 1997 to that in 1998?
Your response must be concise. 1.63. What is the ratio of the Aid flow (current US$) of Burkina Faso in 1997 to that in 1998?
Provide a short and direct response. 0.75. What is the ratio of the Aid flow (current US$) of Guinea-Bissau in 1997 to that in 1998?
Offer a terse response. 0.6. What is the difference between the highest and the second highest Aid flow (current US$) of Latin America(developing only)?
Ensure brevity in your answer.  10000. What is the difference between the highest and the second highest Aid flow (current US$) in Upper middle income?
Offer a terse response. 1.49e+07. What is the difference between the highest and the second highest Aid flow (current US$) in Burkina Faso?
Ensure brevity in your answer.  4.90e+05. What is the difference between the highest and the lowest Aid flow (current US$) of Latin America(developing only)?
Ensure brevity in your answer.  3.80e+07. What is the difference between the highest and the lowest Aid flow (current US$) of Upper middle income?
Your answer should be compact. 1.13e+08. What is the difference between the highest and the lowest Aid flow (current US$) in Burkina Faso?
Your response must be concise. 1.75e+06. What is the difference between the highest and the lowest Aid flow (current US$) of Guinea-Bissau?
Give a very brief answer. 6.67e+06. 